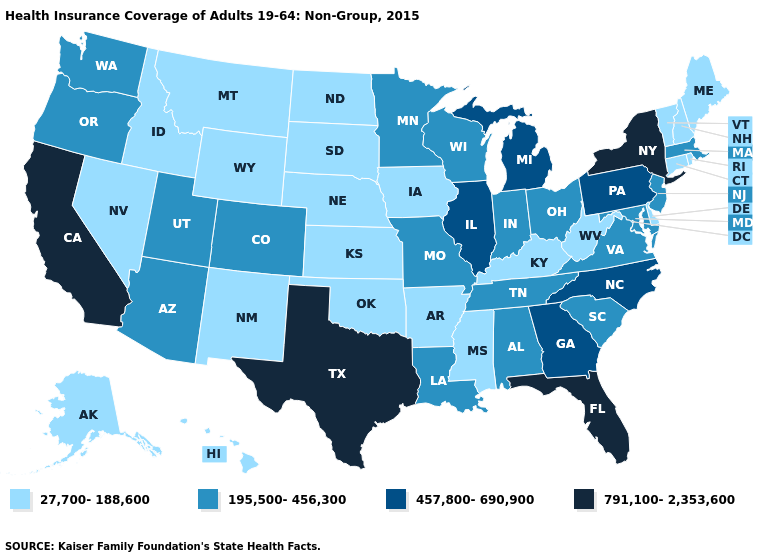What is the highest value in states that border Kentucky?
Write a very short answer. 457,800-690,900. Does Kansas have a lower value than Maine?
Write a very short answer. No. Does the map have missing data?
Write a very short answer. No. What is the value of Ohio?
Short answer required. 195,500-456,300. What is the lowest value in the USA?
Quick response, please. 27,700-188,600. Does Rhode Island have the highest value in the Northeast?
Quick response, please. No. Among the states that border Indiana , which have the lowest value?
Keep it brief. Kentucky. Does Utah have the same value as Vermont?
Quick response, please. No. Does the first symbol in the legend represent the smallest category?
Give a very brief answer. Yes. What is the highest value in states that border Michigan?
Keep it brief. 195,500-456,300. What is the value of Virginia?
Keep it brief. 195,500-456,300. Name the states that have a value in the range 791,100-2,353,600?
Answer briefly. California, Florida, New York, Texas. Does the map have missing data?
Quick response, please. No. Among the states that border Missouri , which have the lowest value?
Give a very brief answer. Arkansas, Iowa, Kansas, Kentucky, Nebraska, Oklahoma. Among the states that border Wyoming , which have the highest value?
Write a very short answer. Colorado, Utah. 